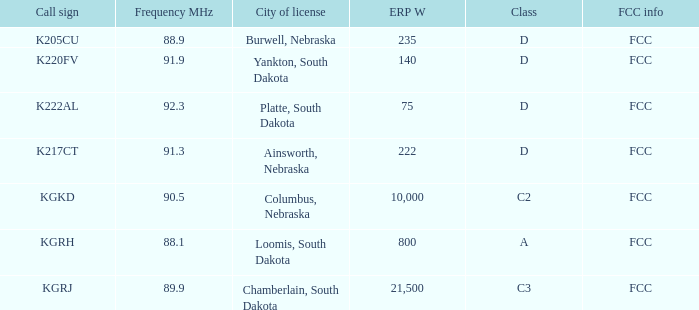What is the average frequency mhz of the loomis, south dakota city license? 88.1. 